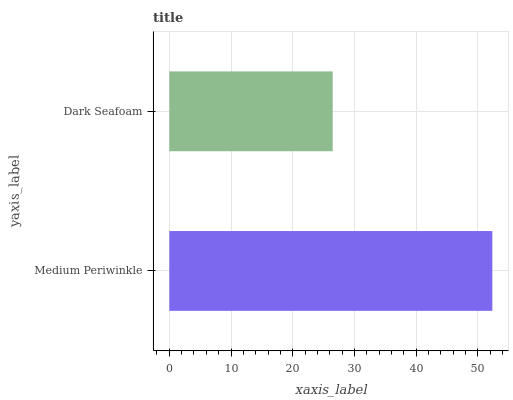Is Dark Seafoam the minimum?
Answer yes or no. Yes. Is Medium Periwinkle the maximum?
Answer yes or no. Yes. Is Dark Seafoam the maximum?
Answer yes or no. No. Is Medium Periwinkle greater than Dark Seafoam?
Answer yes or no. Yes. Is Dark Seafoam less than Medium Periwinkle?
Answer yes or no. Yes. Is Dark Seafoam greater than Medium Periwinkle?
Answer yes or no. No. Is Medium Periwinkle less than Dark Seafoam?
Answer yes or no. No. Is Medium Periwinkle the high median?
Answer yes or no. Yes. Is Dark Seafoam the low median?
Answer yes or no. Yes. Is Dark Seafoam the high median?
Answer yes or no. No. Is Medium Periwinkle the low median?
Answer yes or no. No. 